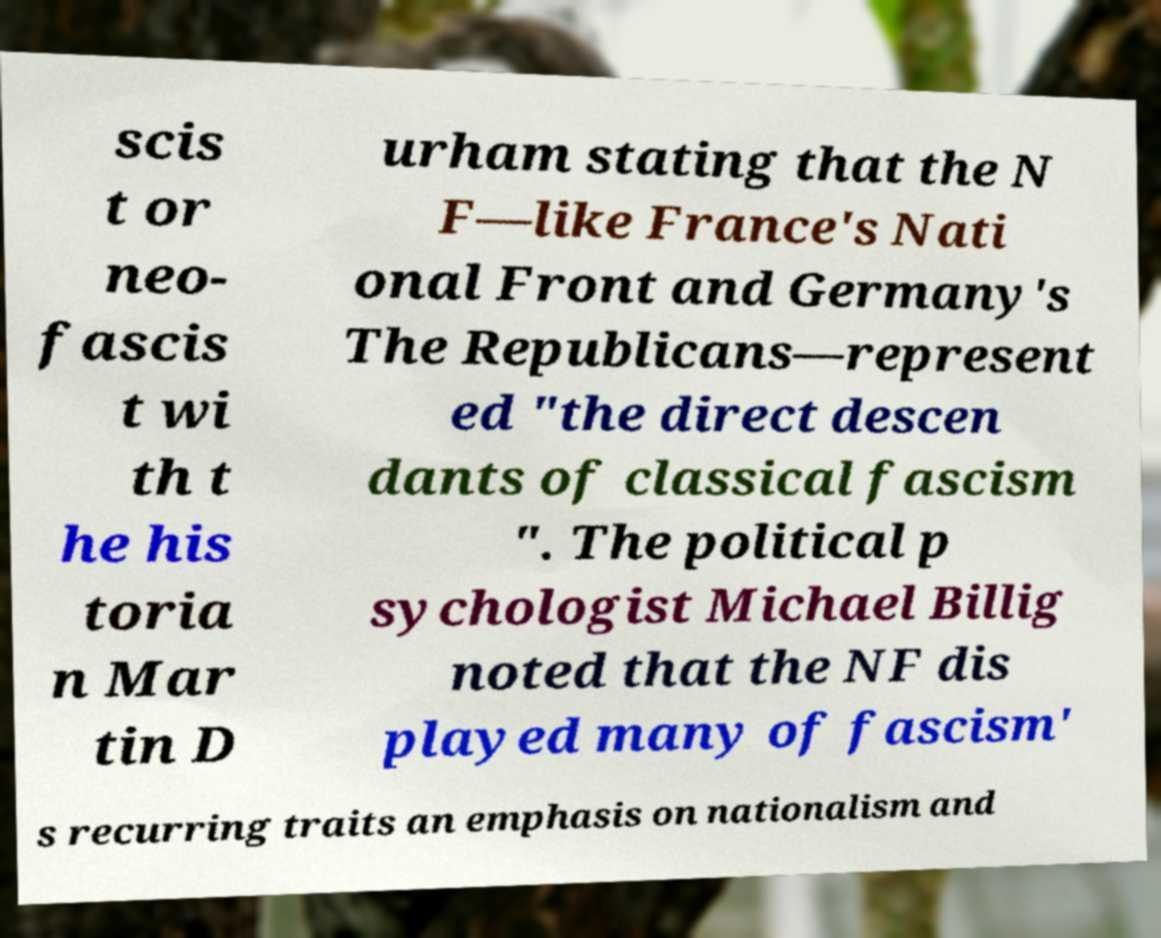Can you read and provide the text displayed in the image?This photo seems to have some interesting text. Can you extract and type it out for me? scis t or neo- fascis t wi th t he his toria n Mar tin D urham stating that the N F—like France's Nati onal Front and Germany's The Republicans—represent ed "the direct descen dants of classical fascism ". The political p sychologist Michael Billig noted that the NF dis played many of fascism' s recurring traits an emphasis on nationalism and 